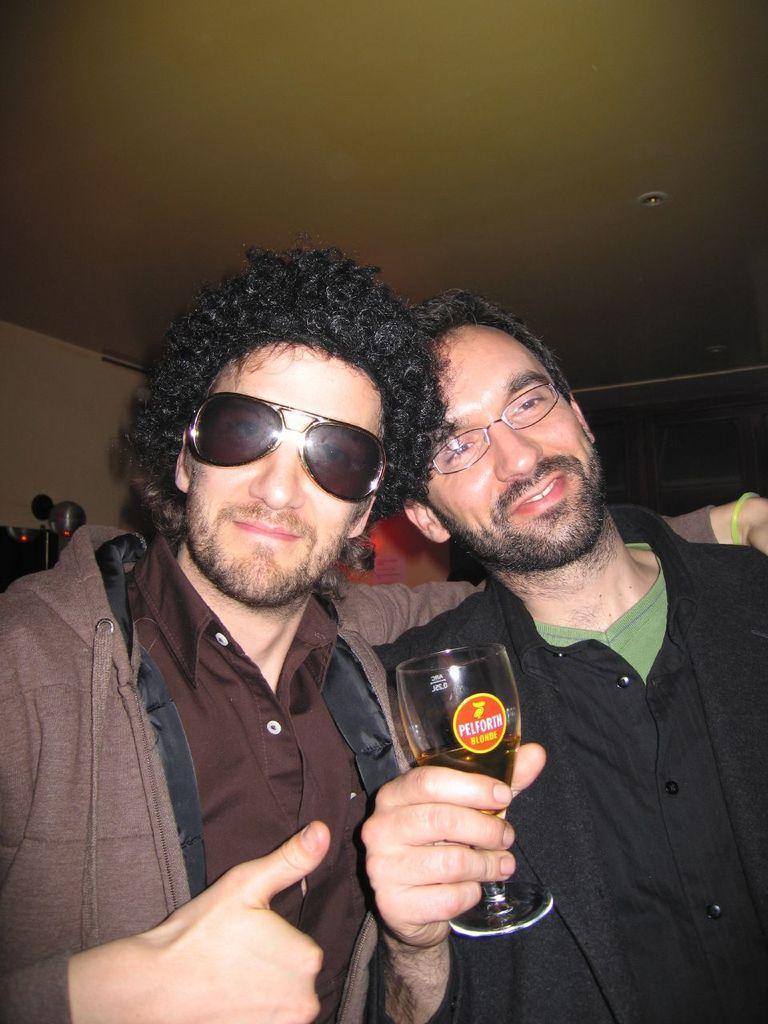How many people are in the image? There are two persons in the image. What are the people wearing? Both persons are wearing spectacles. What is one person holding in the image? One person is holding a glass. What can be seen at the top of the image? There is a roof visible at the top of the image. What type of land can be seen in the image? There is no land visible in the image; it only shows two people and a roof. What kind of blade is being used by one of the persons in the image? There is no blade present in the image; both persons are wearing spectacles and one is holding a glass. 